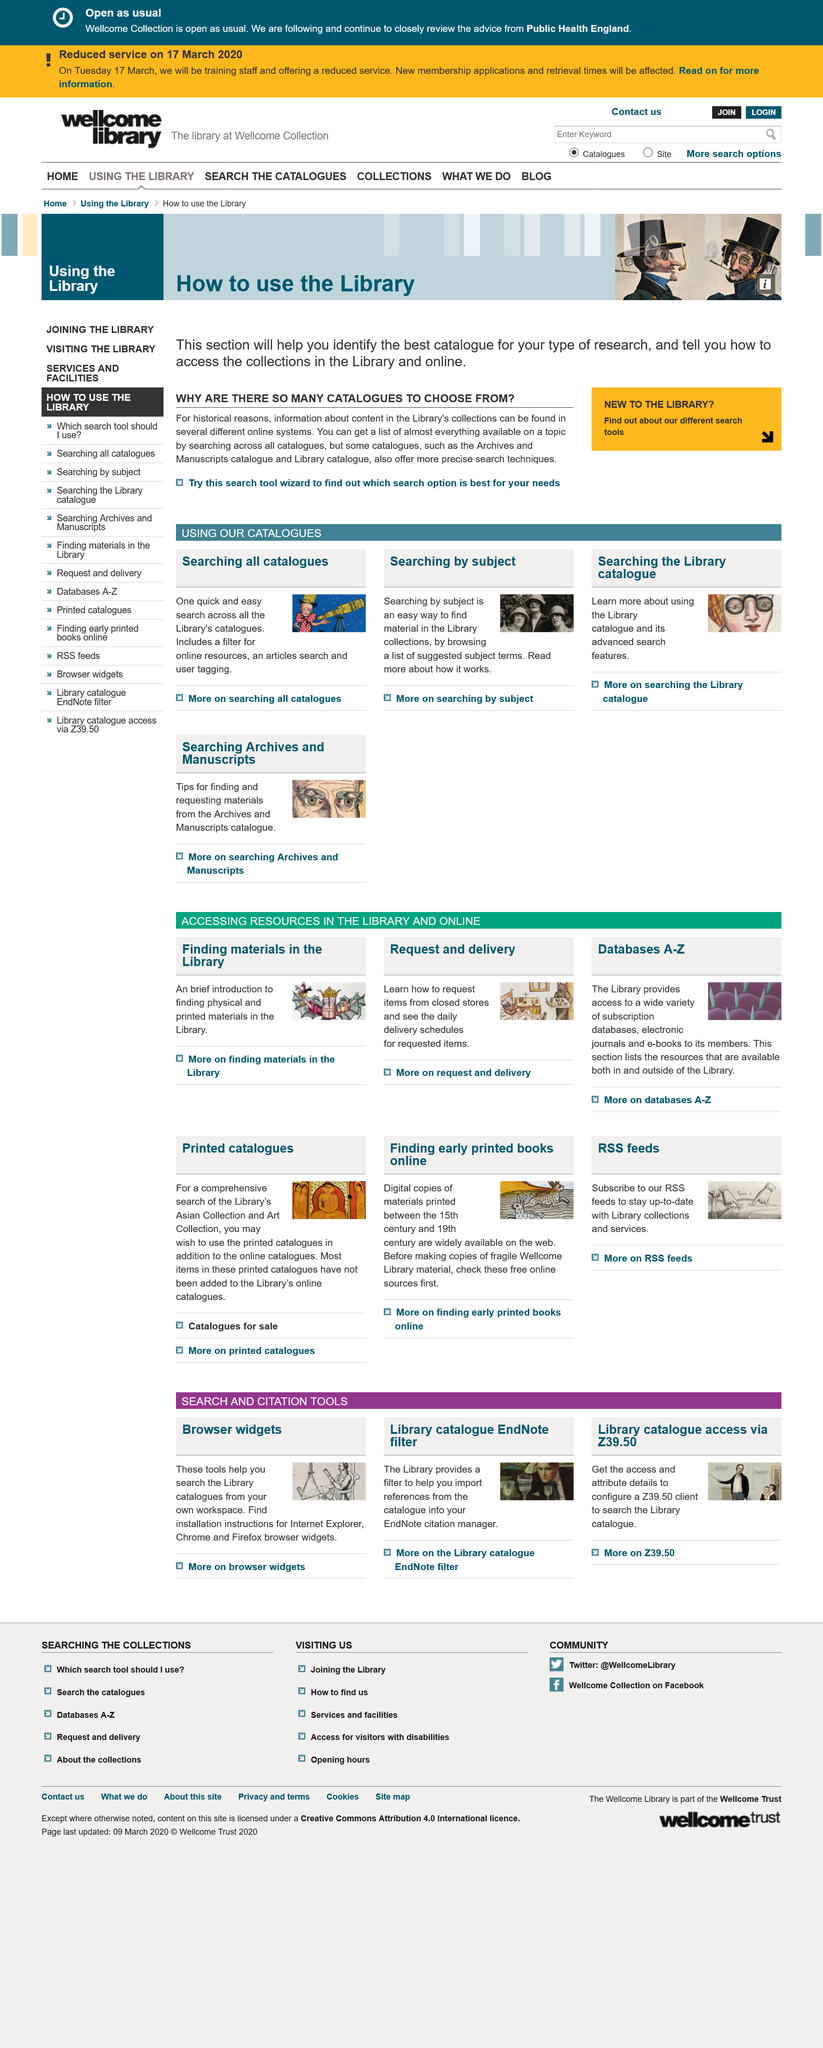Identify some key points in this picture. This page is about catalogues. The title of this page is "WHY ARE THERE SO MANY CATALOGUES TO CHOOSE FROM?" The Library's collections contain information that can be found in multiple online systems due to historical reasons. 